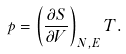Convert formula to latex. <formula><loc_0><loc_0><loc_500><loc_500>p = \left ( \frac { \partial S } { \partial V } \right ) _ { N , E } T .</formula> 